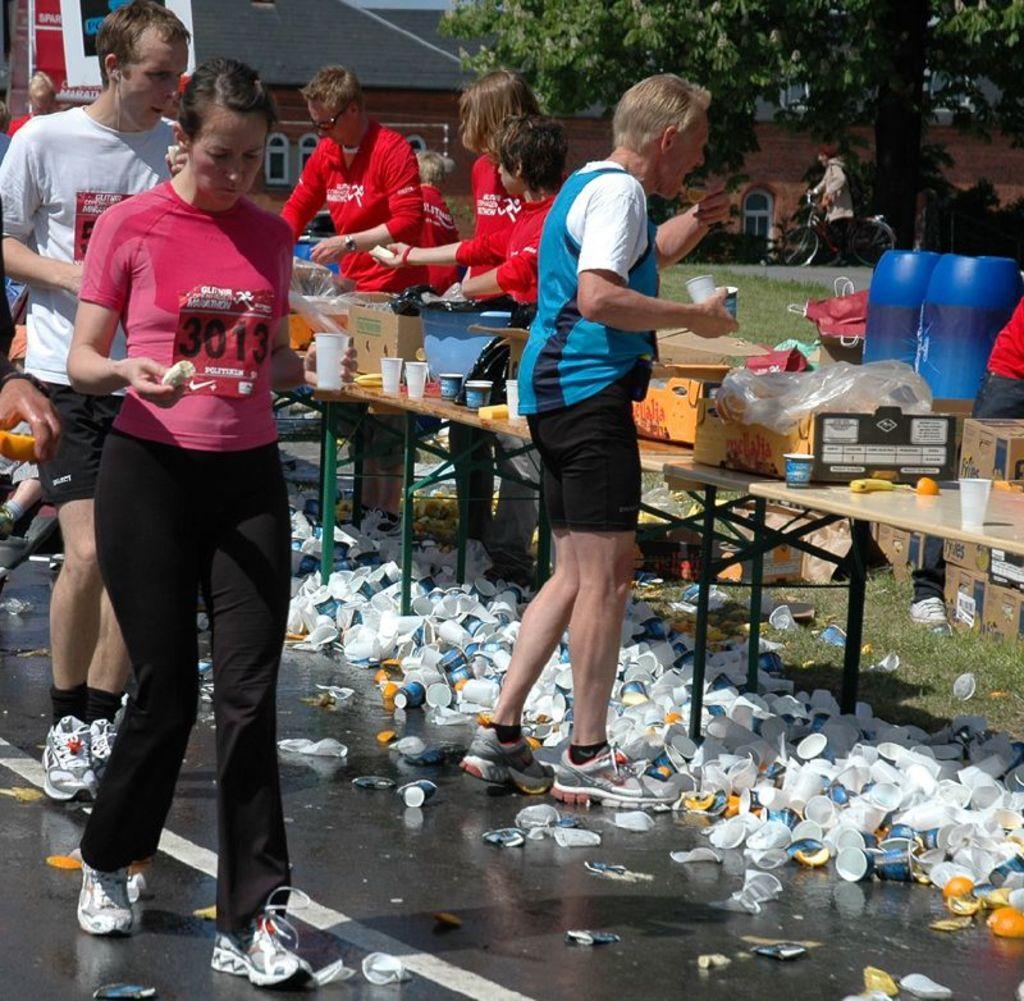Please provide a concise description of this image. This image is taken outdoors. At the bottom of the image there is a road and there are many used cups and fruit peels on the road. On the left side of the image a man and a woman are walking on the road and a woman is holding a fruit and a glass in her hands. In the background there is a building. There is a tree and there are a few boards with text on them. A man is riding the bicycle. In the middle of the image a few people are standing and there are a few tables with many things on them. On the right side of the image there are a few cardboard boxes. There is a man and there are two drums. 